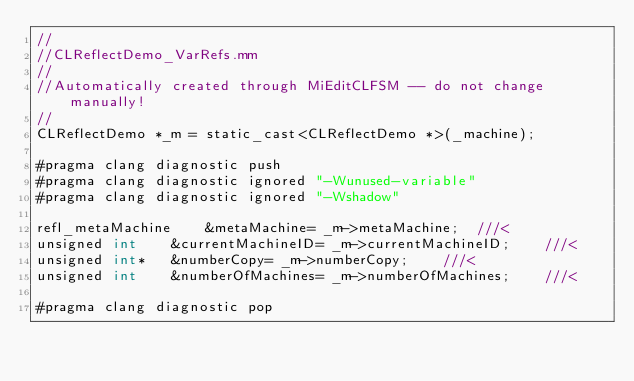Convert code to text. <code><loc_0><loc_0><loc_500><loc_500><_ObjectiveC_>//
//CLReflectDemo_VarRefs.mm
//
//Automatically created through MiEditCLFSM -- do not change manually!
//
CLReflectDemo *_m = static_cast<CLReflectDemo *>(_machine);

#pragma clang diagnostic push
#pragma clang diagnostic ignored "-Wunused-variable"
#pragma clang diagnostic ignored "-Wshadow"

refl_metaMachine	&metaMachine= _m->metaMachine;	///<
unsigned int	&currentMachineID= _m->currentMachineID;	///<
unsigned int*	&numberCopy= _m->numberCopy;	///<
unsigned int	&numberOfMachines= _m->numberOfMachines;	///<

#pragma clang diagnostic pop
</code> 